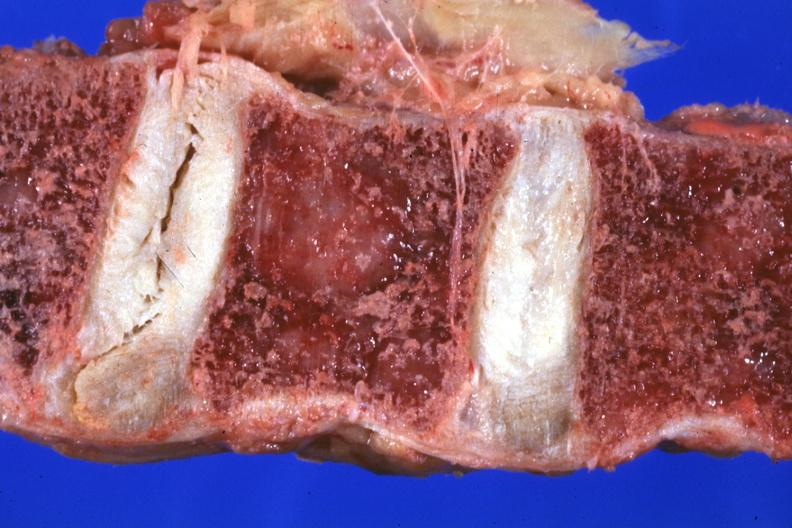what does this image show?
Answer the question using a single word or phrase. Close-up vertebral body excellent 